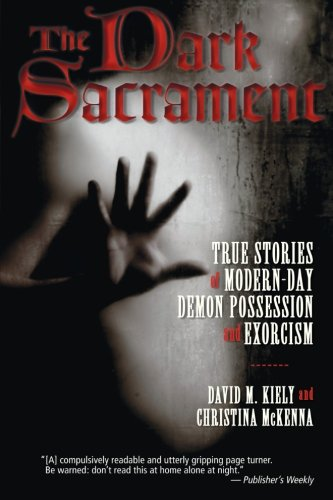Is this book related to Religion & Spirituality? Yes, the book delves into the realm of Religion & Spirituality, particularly focusing on phenomena reported in these contexts. 